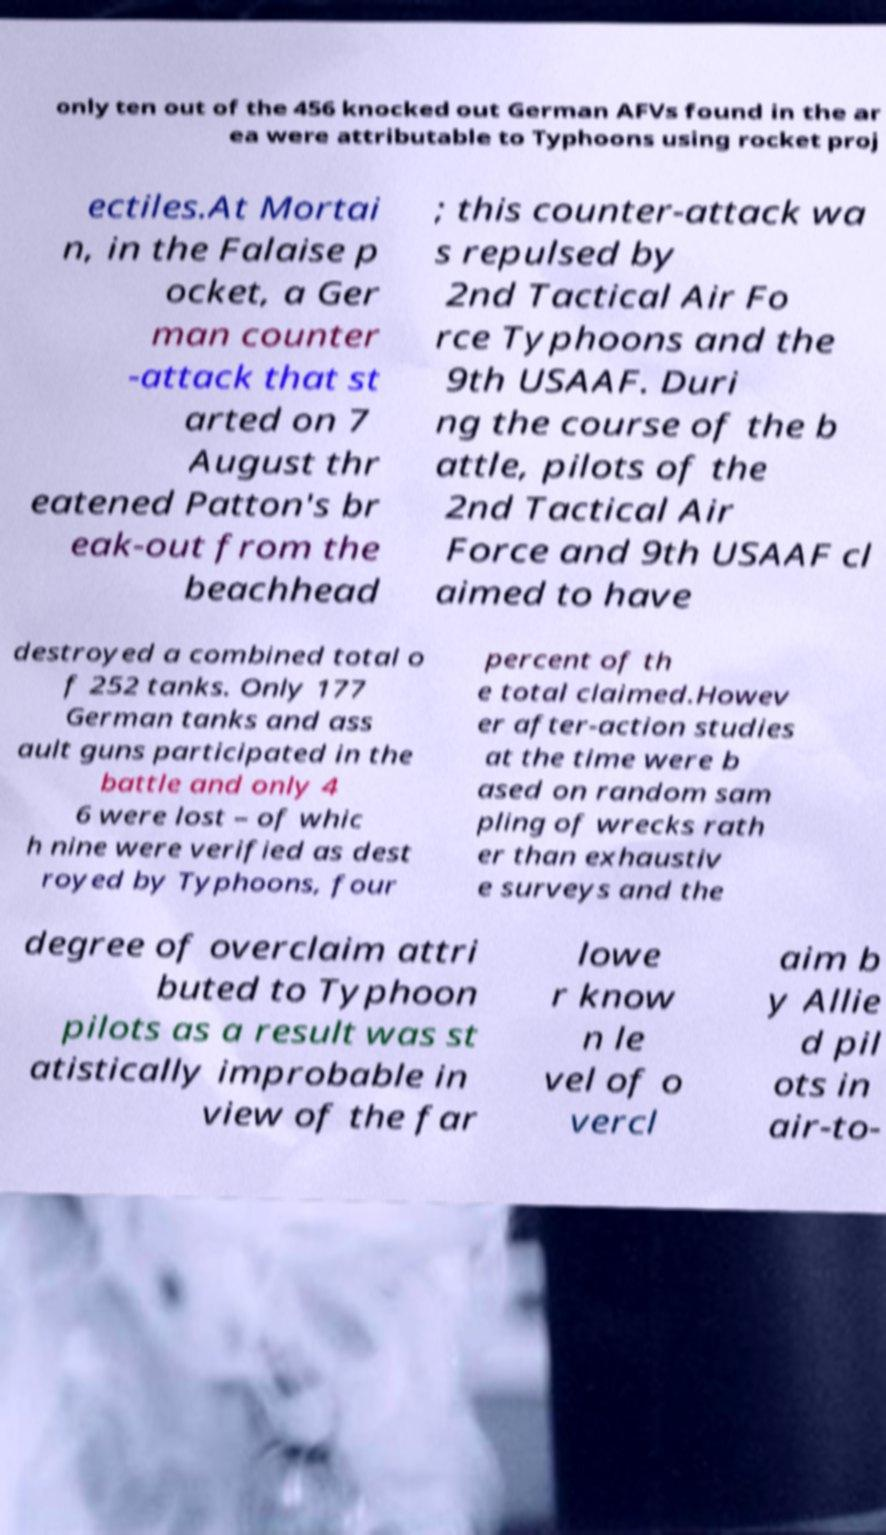I need the written content from this picture converted into text. Can you do that? only ten out of the 456 knocked out German AFVs found in the ar ea were attributable to Typhoons using rocket proj ectiles.At Mortai n, in the Falaise p ocket, a Ger man counter -attack that st arted on 7 August thr eatened Patton's br eak-out from the beachhead ; this counter-attack wa s repulsed by 2nd Tactical Air Fo rce Typhoons and the 9th USAAF. Duri ng the course of the b attle, pilots of the 2nd Tactical Air Force and 9th USAAF cl aimed to have destroyed a combined total o f 252 tanks. Only 177 German tanks and ass ault guns participated in the battle and only 4 6 were lost – of whic h nine were verified as dest royed by Typhoons, four percent of th e total claimed.Howev er after-action studies at the time were b ased on random sam pling of wrecks rath er than exhaustiv e surveys and the degree of overclaim attri buted to Typhoon pilots as a result was st atistically improbable in view of the far lowe r know n le vel of o vercl aim b y Allie d pil ots in air-to- 